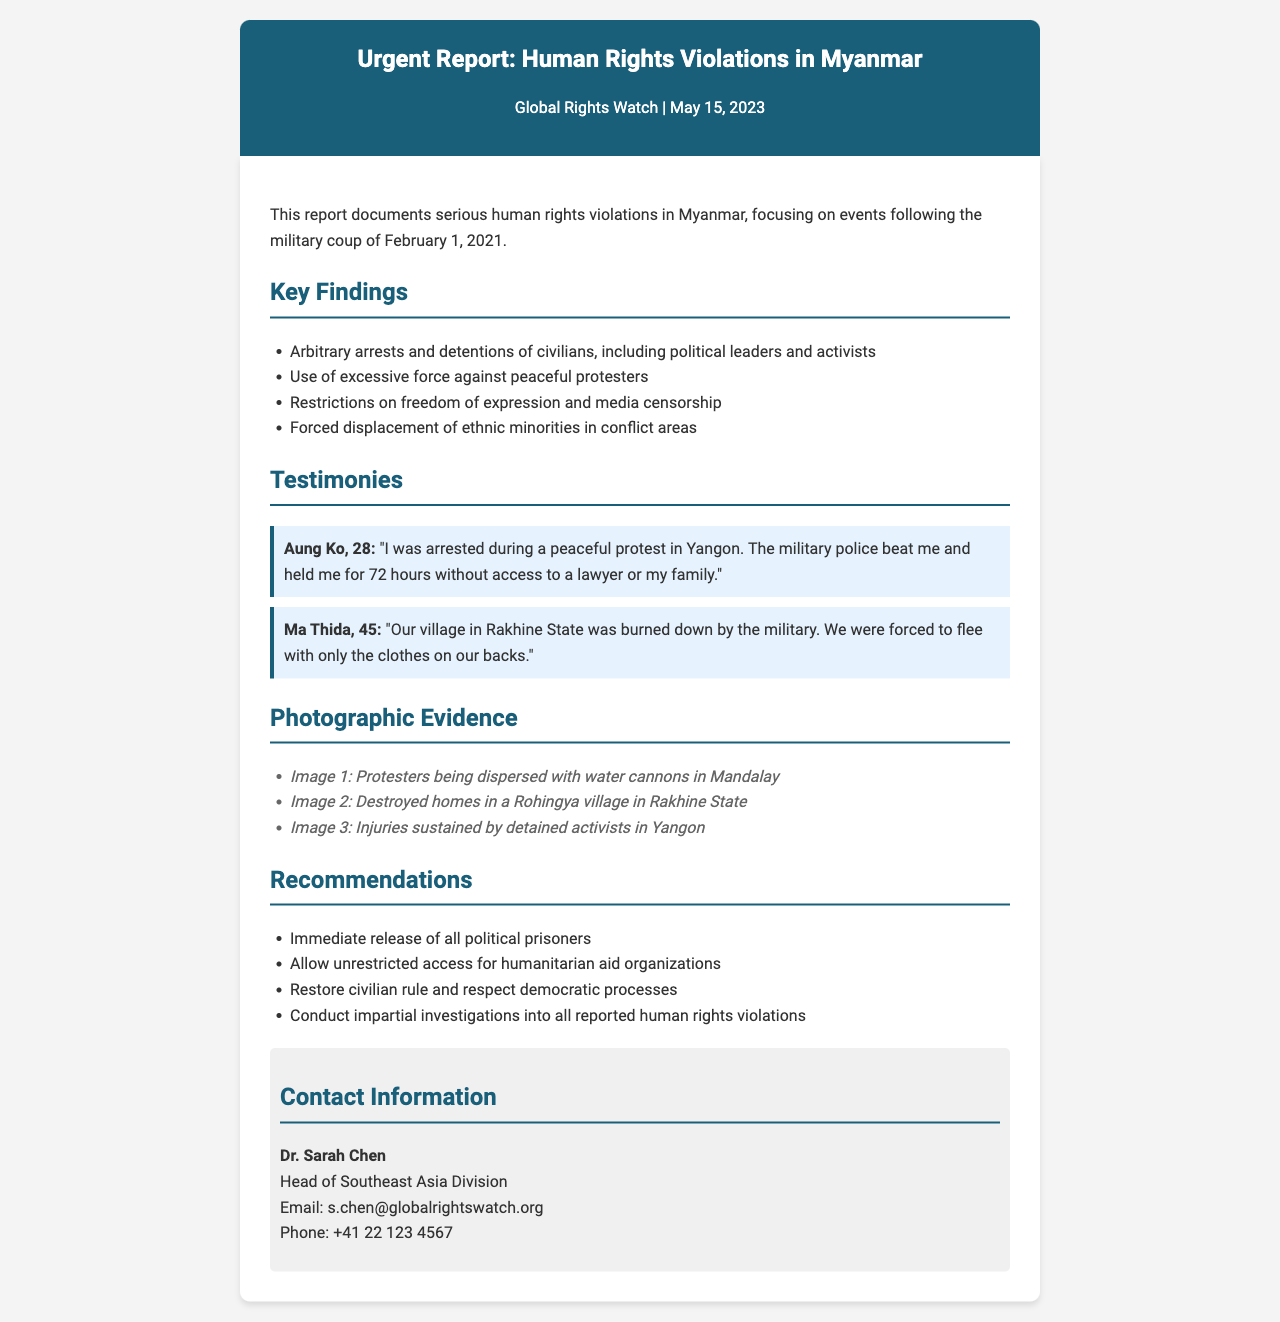What is the title of the report? The title is stated in the header of the document.
Answer: Urgent Report: Human Rights Violations in Myanmar Who authored the report? The author is listed just below the title in the header.
Answer: Global Rights Watch What date was the report published? The date of publication is indicated in the header.
Answer: May 15, 2023 How many testimonies are included in the report? The number of testimonies is found in the "Testimonies" section.
Answer: 2 What recommendations are made regarding political prisoners? The recommendations are listed in the "Recommendations" section of the document.
Answer: Immediate release of all political prisoners What type of force was used against peaceful protesters? The type of force mentioned in the key findings describes actions against protesters.
Answer: Excessive force In which state was a village burned down according to the testimonies? The location is specified in one of the testimonies.
Answer: Rakhine State What is the email of the head of Southeast Asia Division? Contact information for Dr. Sarah Chen provides her email.
Answer: s.chen@globalrightswatch.org 